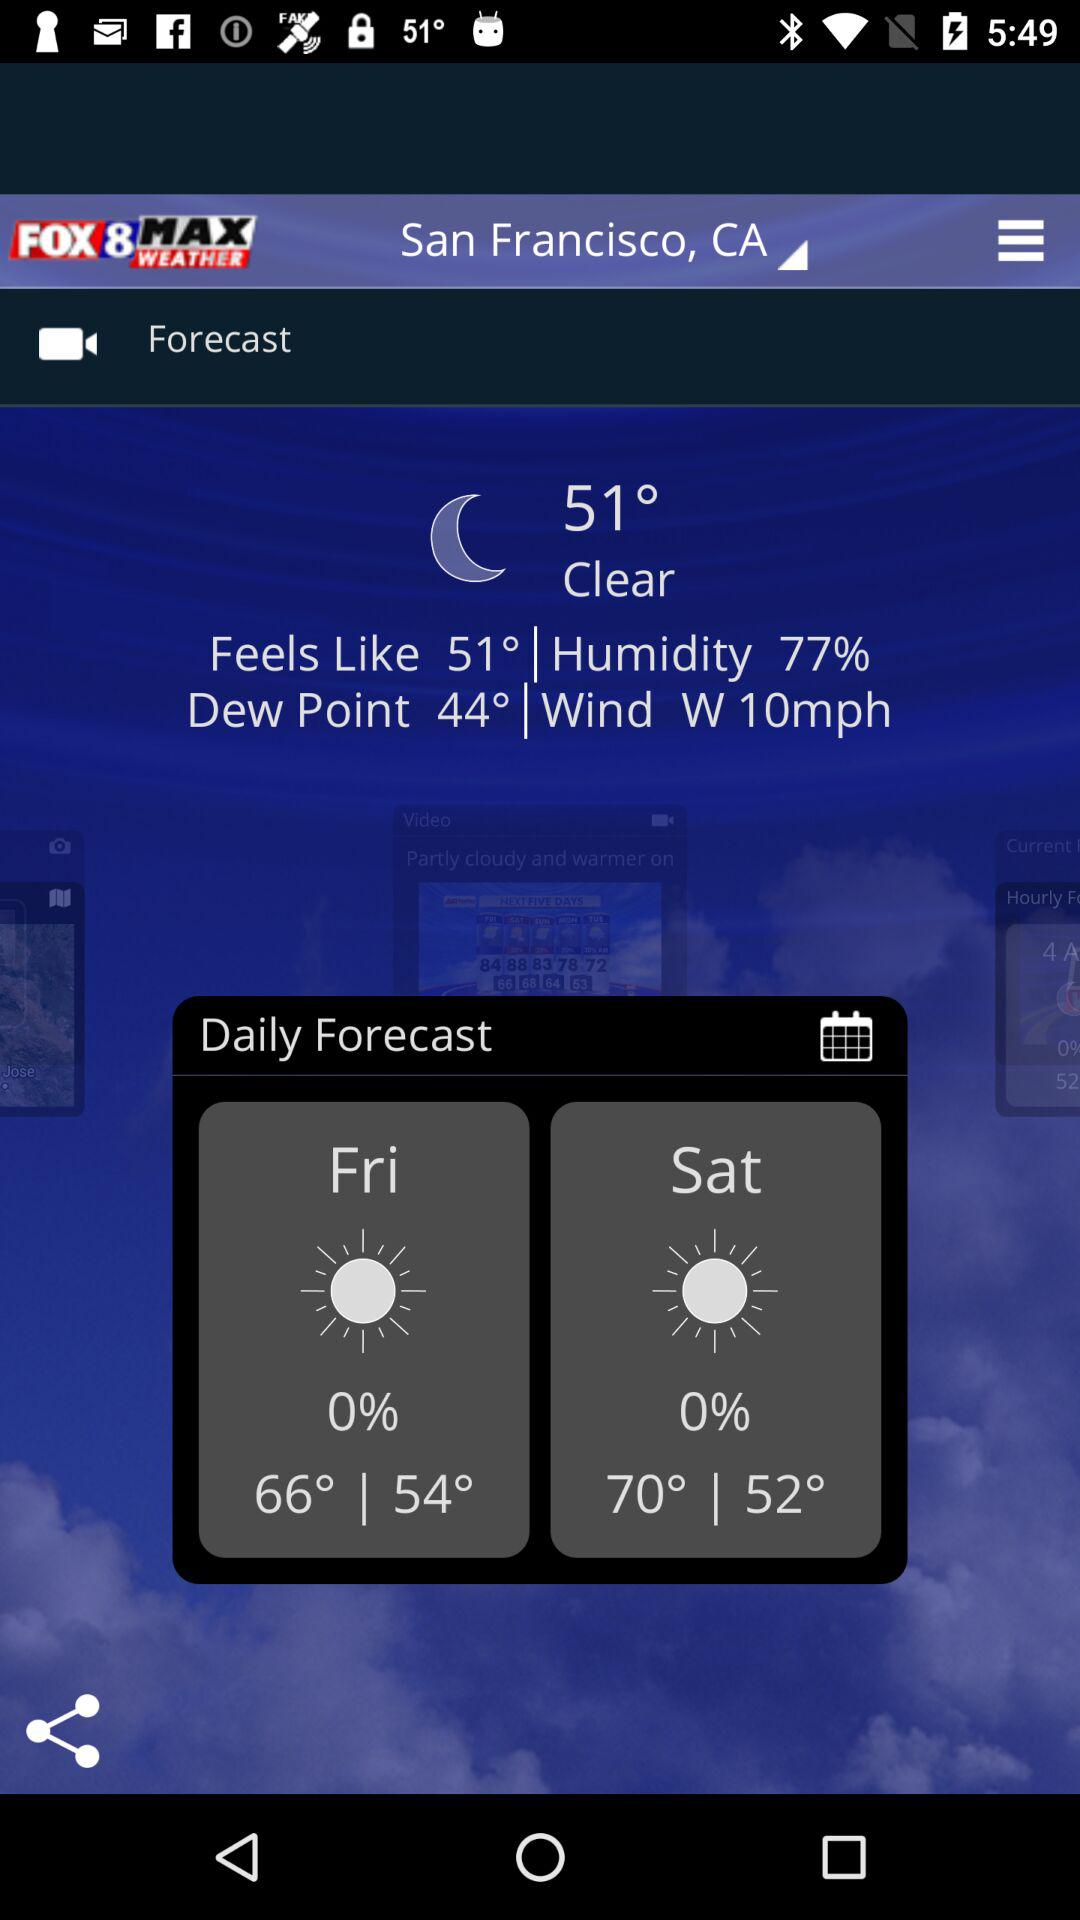How many days are in the forecast?
Answer the question using a single word or phrase. 2 